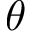Convert formula to latex. <formula><loc_0><loc_0><loc_500><loc_500>\theta</formula> 